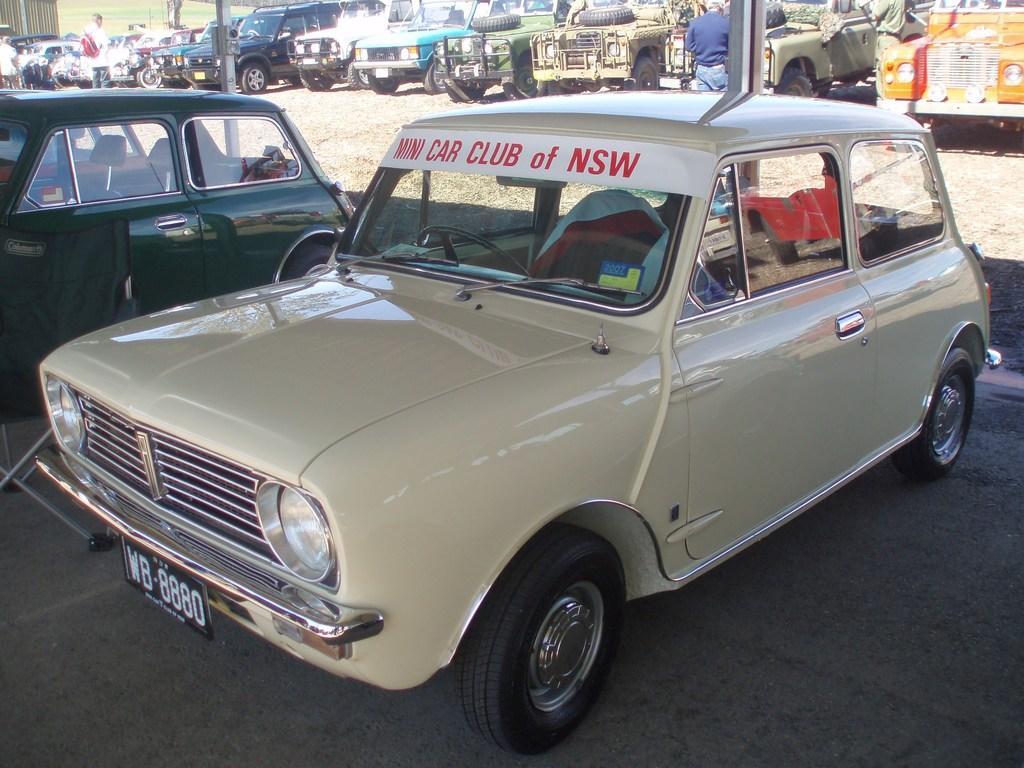Could you give a brief overview of what you see in this image? In this image there are cars on the road and there are persons. In the background there is grass on the ground. In the front there is car, on the car there is some text written on it. 